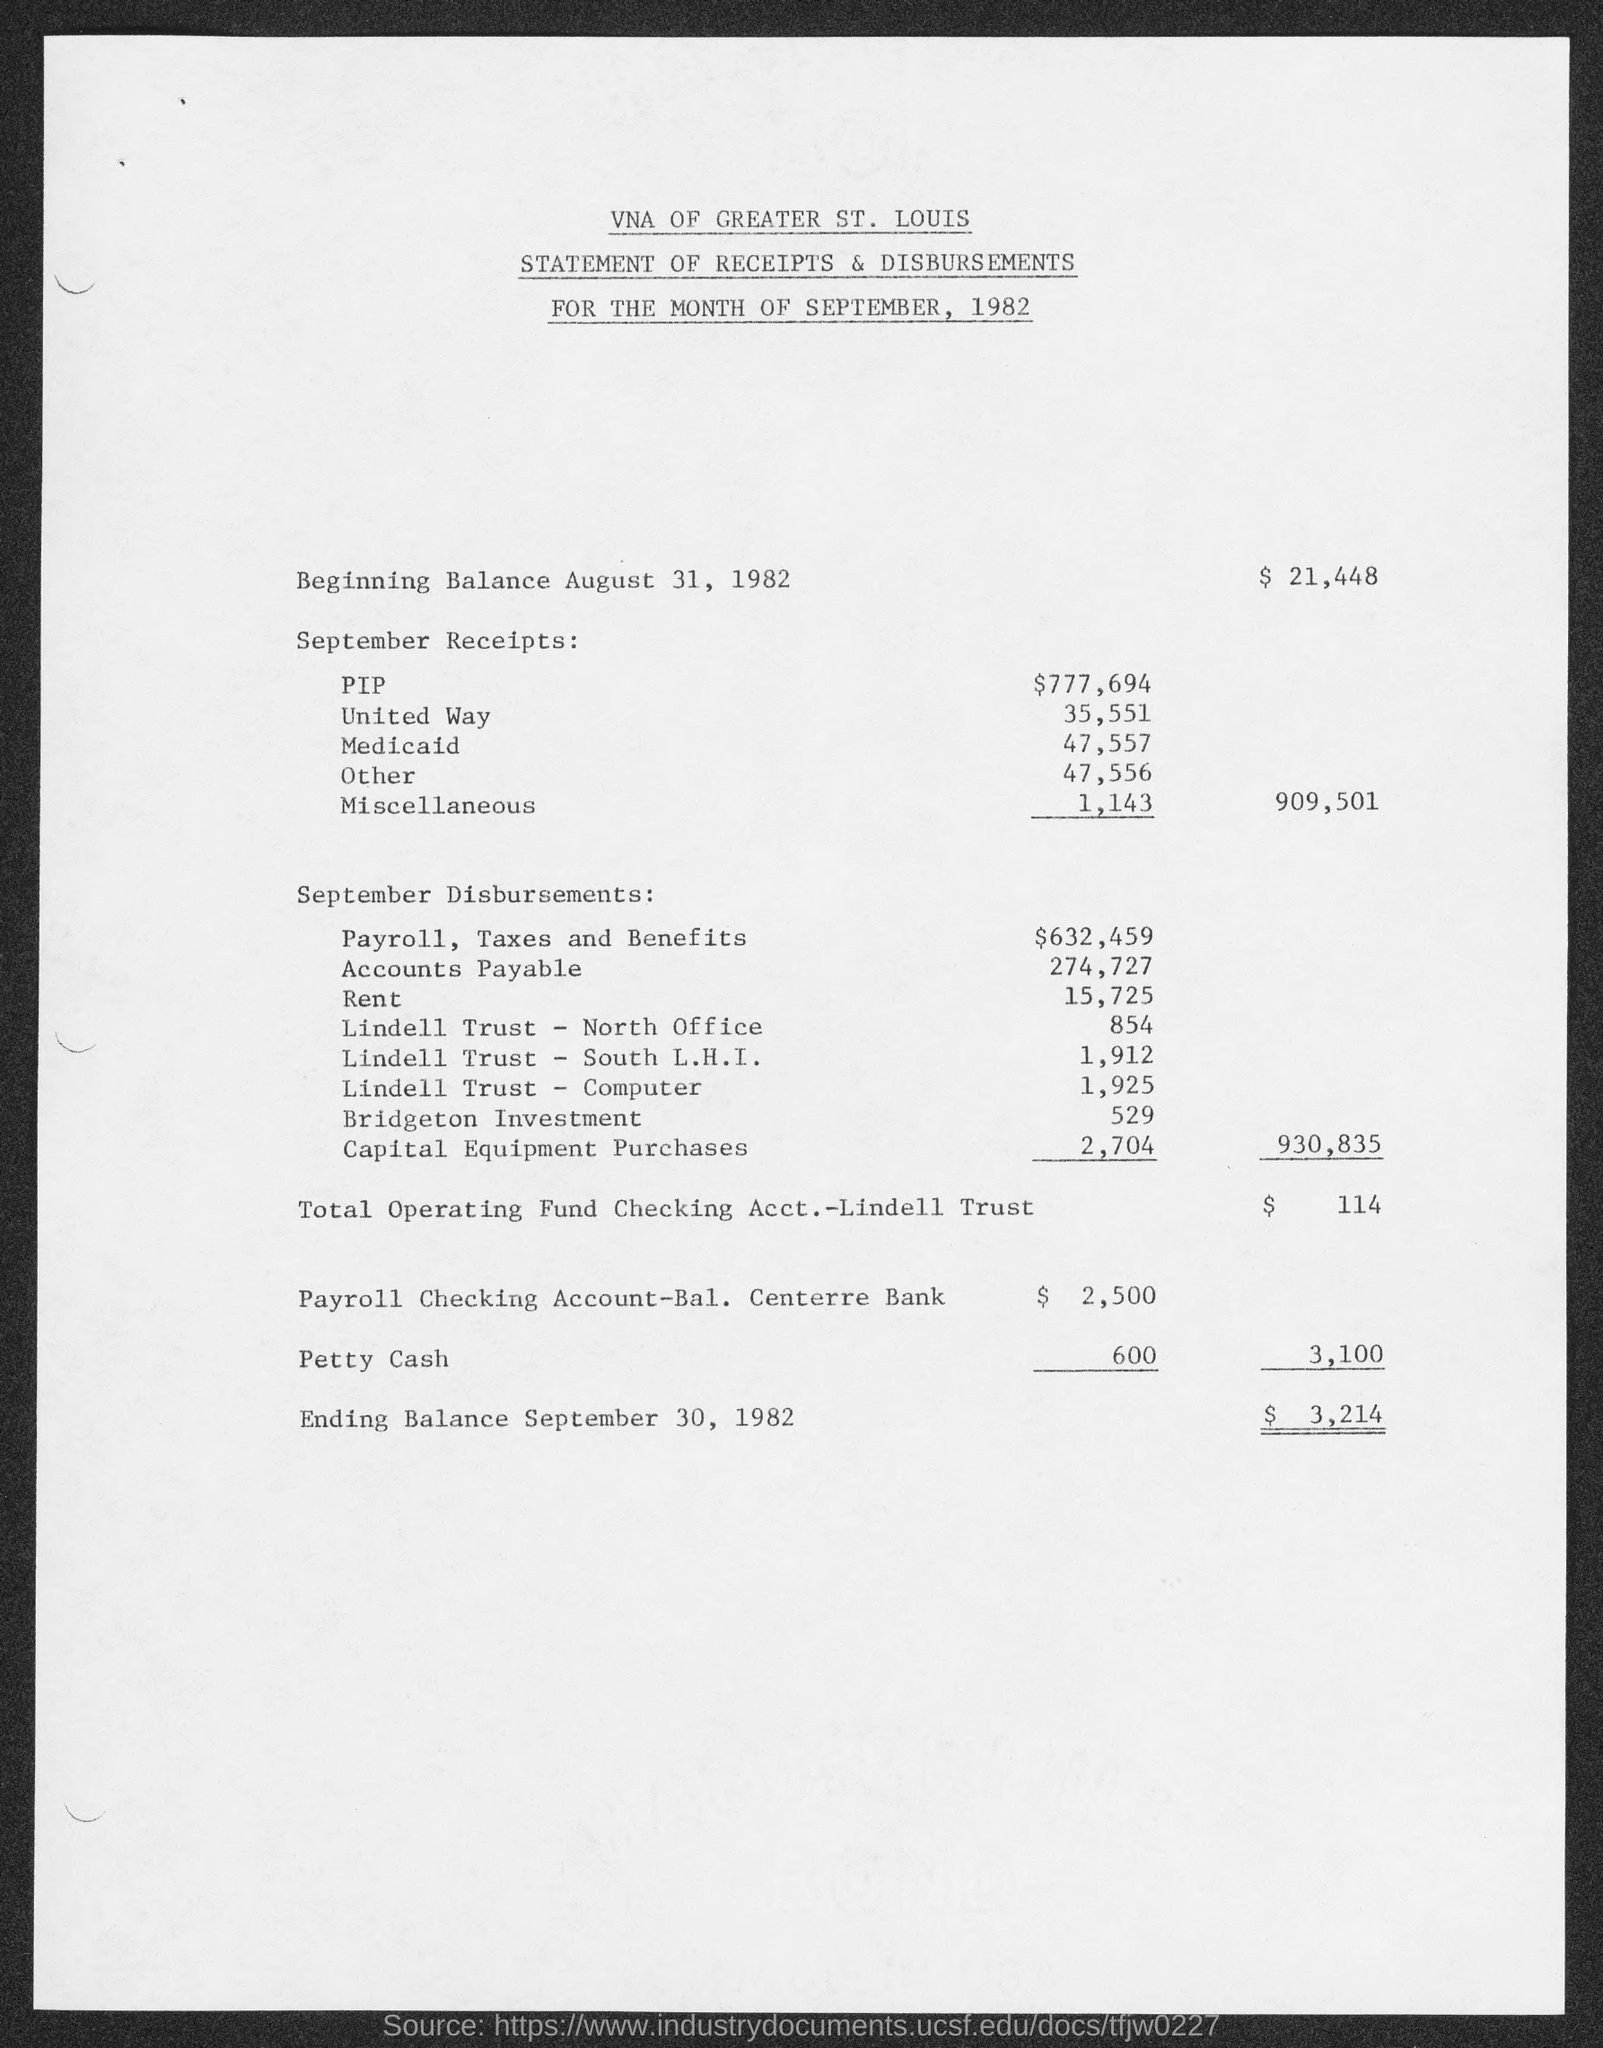What is the first title in the document?
Keep it short and to the point. VNA of Greater St. Louis. What is the second title in the document?
Keep it short and to the point. Statement of Receipts & Disbursements. What is the third title in the document?
Offer a very short reply. For the month of september, 1982. What is the rent?
Provide a succinct answer. 15,725. What is the miscellaneous amount?
Give a very brief answer. 1,143. What is the amount for capital equipment purchases?
Ensure brevity in your answer.  2,704. 